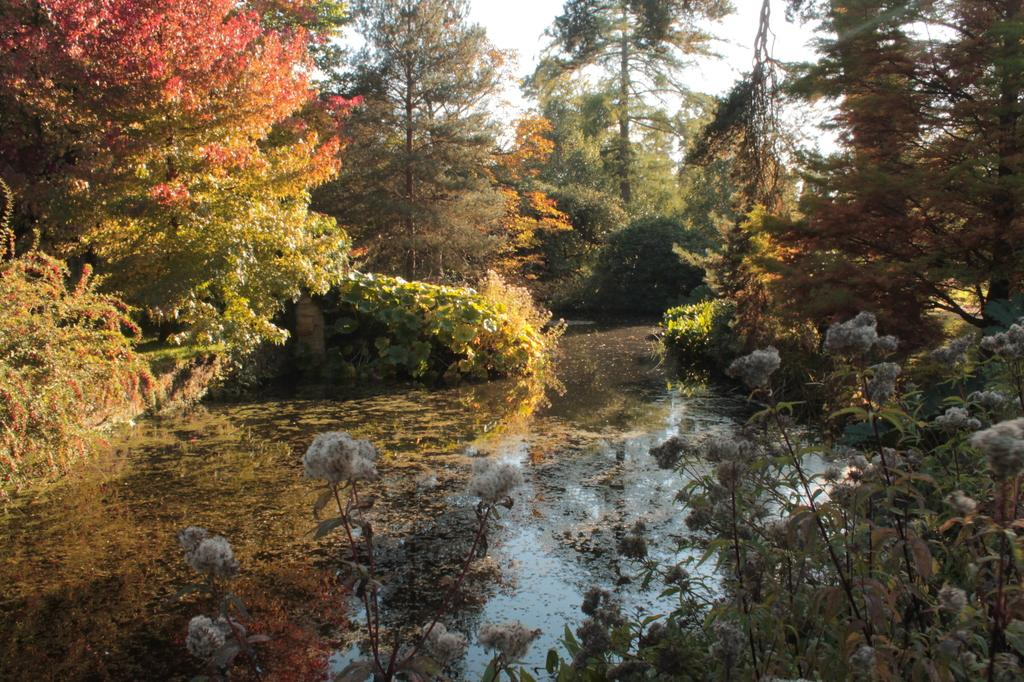What type of living organisms can be seen in the image? Plants and trees are visible in the image. What natural element is present in the image? Water is visible in the image. What part of the natural environment is visible in the image? The sky is visible in the image. What type of leather can be seen in the image? There is no leather present in the image. How is the beef being prepared in the image? There is no beef present in the image. 